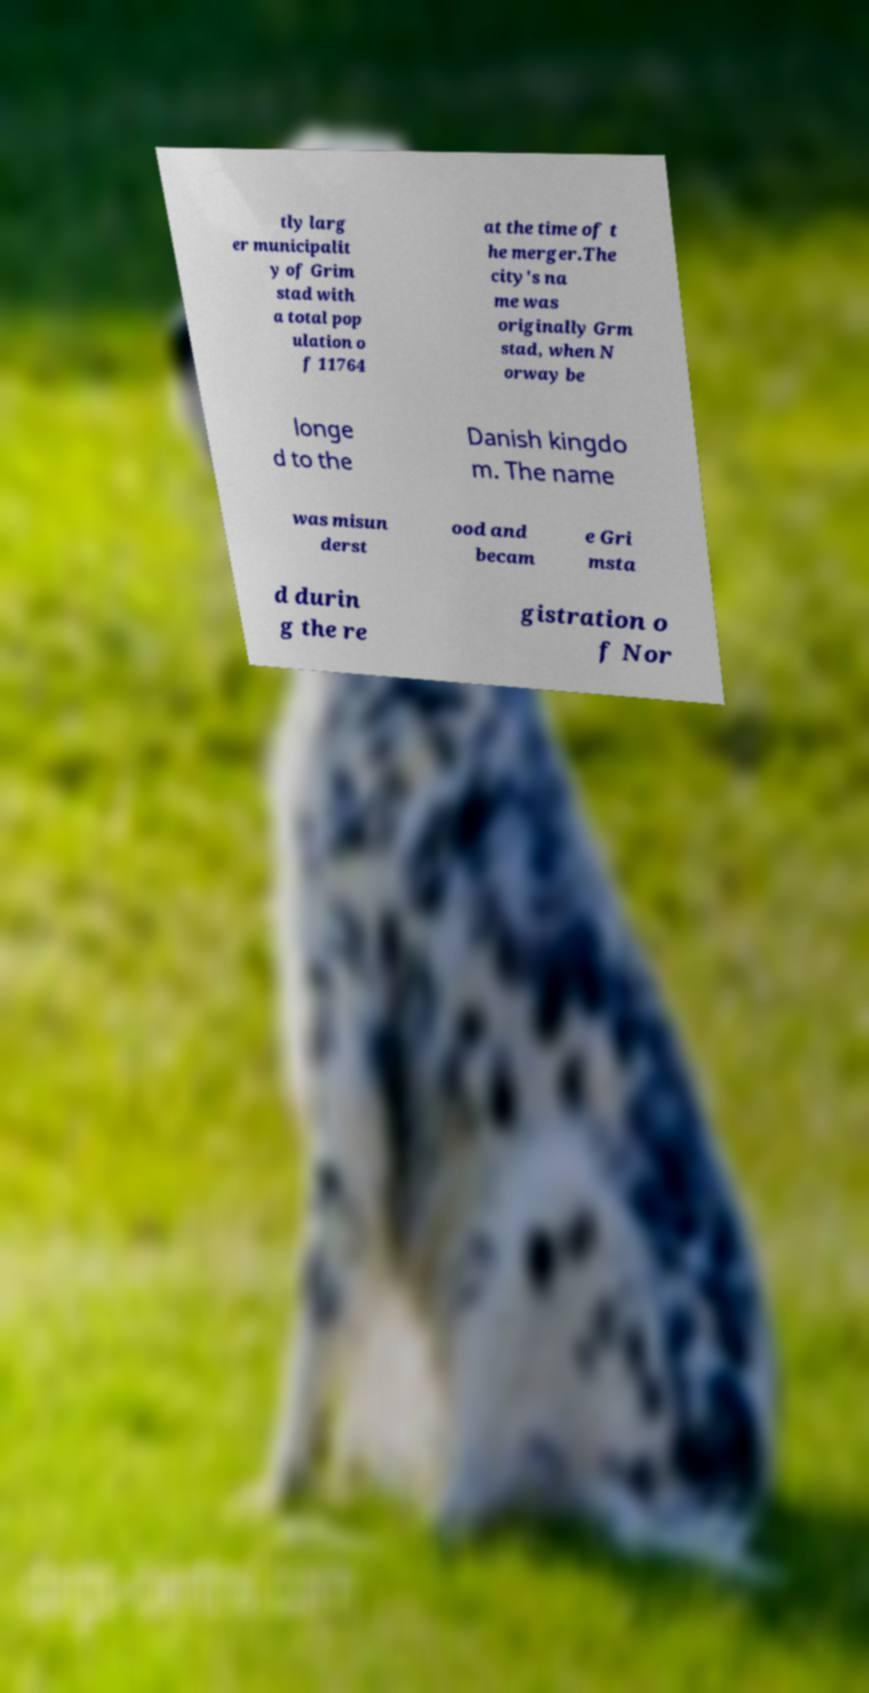Please read and relay the text visible in this image. What does it say? tly larg er municipalit y of Grim stad with a total pop ulation o f 11764 at the time of t he merger.The city's na me was originally Grm stad, when N orway be longe d to the Danish kingdo m. The name was misun derst ood and becam e Gri msta d durin g the re gistration o f Nor 